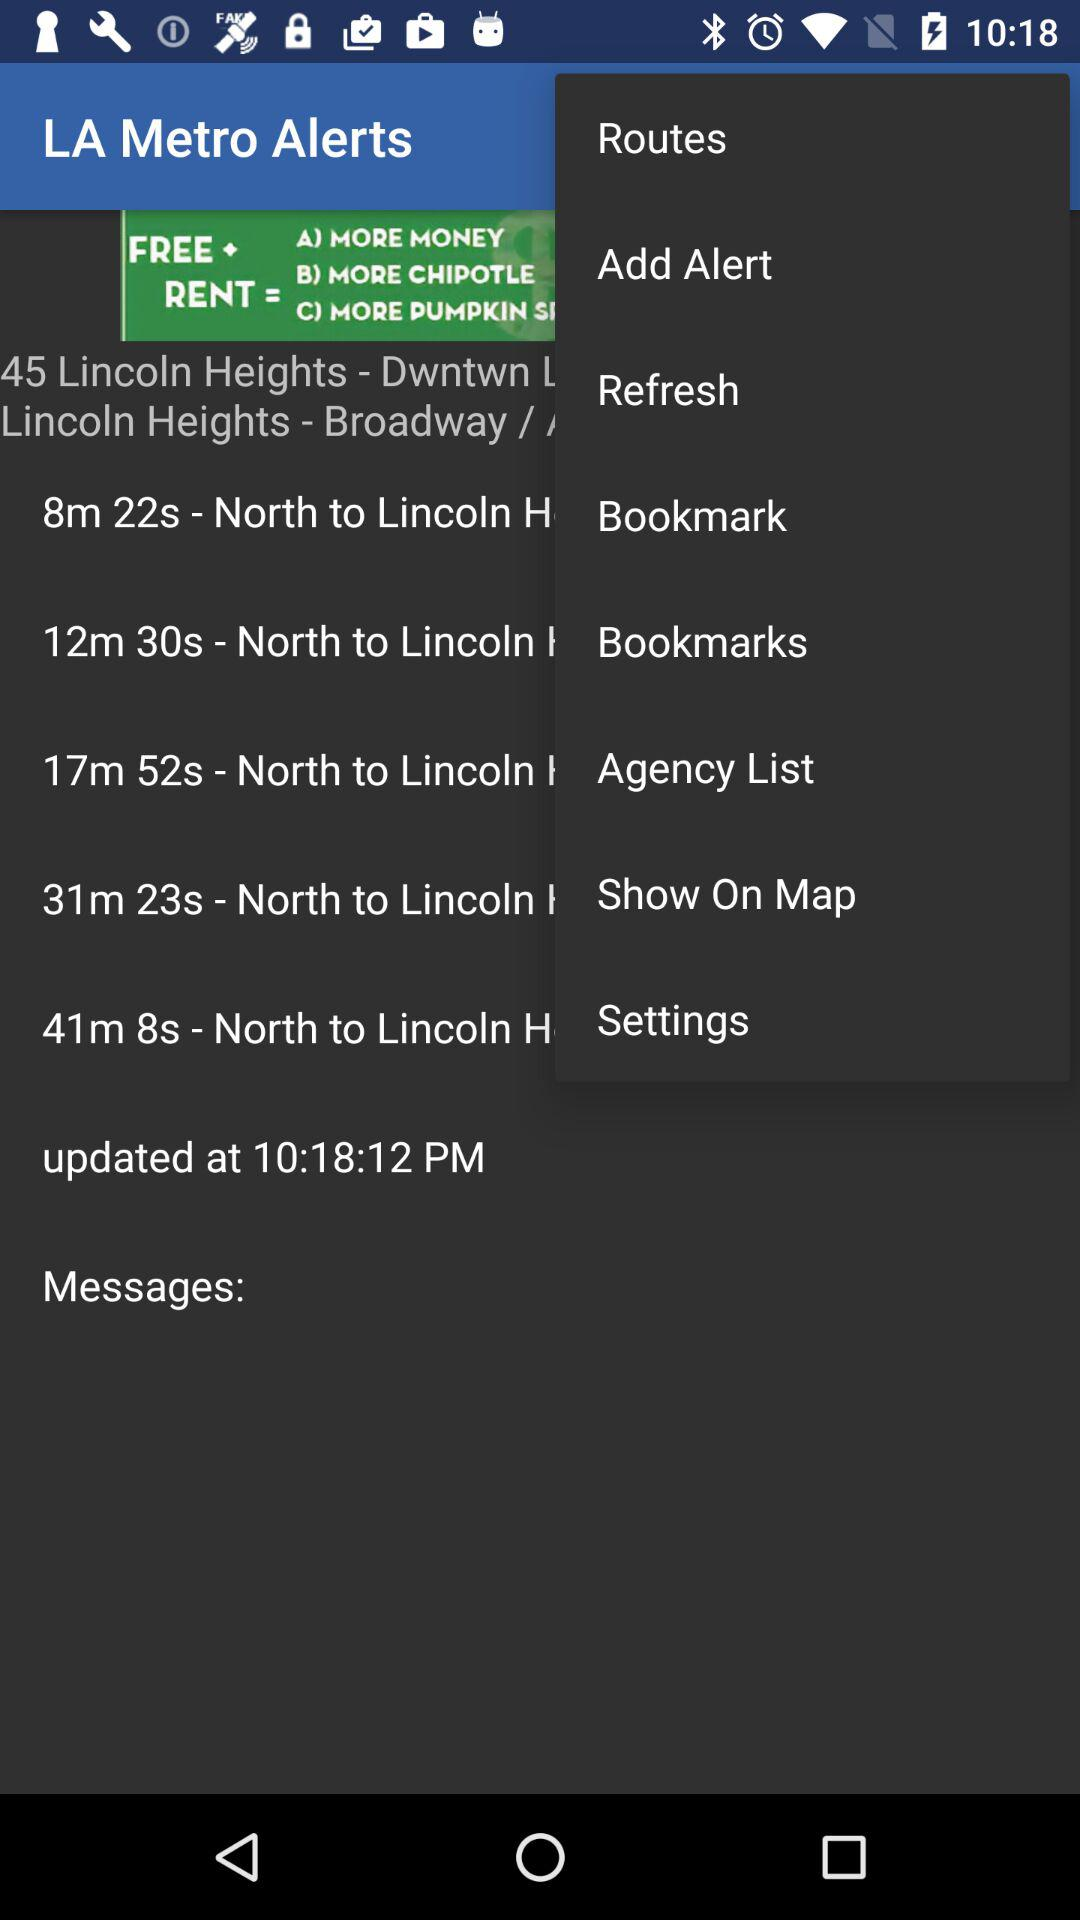What time was the last update done? The last update was done at 10:18:12 PM. 